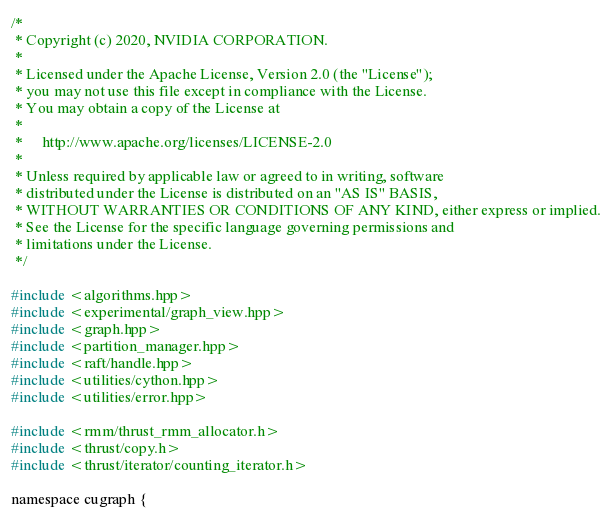Convert code to text. <code><loc_0><loc_0><loc_500><loc_500><_Cuda_>/*
 * Copyright (c) 2020, NVIDIA CORPORATION.
 *
 * Licensed under the Apache License, Version 2.0 (the "License");
 * you may not use this file except in compliance with the License.
 * You may obtain a copy of the License at
 *
 *     http://www.apache.org/licenses/LICENSE-2.0
 *
 * Unless required by applicable law or agreed to in writing, software
 * distributed under the License is distributed on an "AS IS" BASIS,
 * WITHOUT WARRANTIES OR CONDITIONS OF ANY KIND, either express or implied.
 * See the License for the specific language governing permissions and
 * limitations under the License.
 */

#include <algorithms.hpp>
#include <experimental/graph_view.hpp>
#include <graph.hpp>
#include <partition_manager.hpp>
#include <raft/handle.hpp>
#include <utilities/cython.hpp>
#include <utilities/error.hpp>

#include <rmm/thrust_rmm_allocator.h>
#include <thrust/copy.h>
#include <thrust/iterator/counting_iterator.h>

namespace cugraph {</code> 